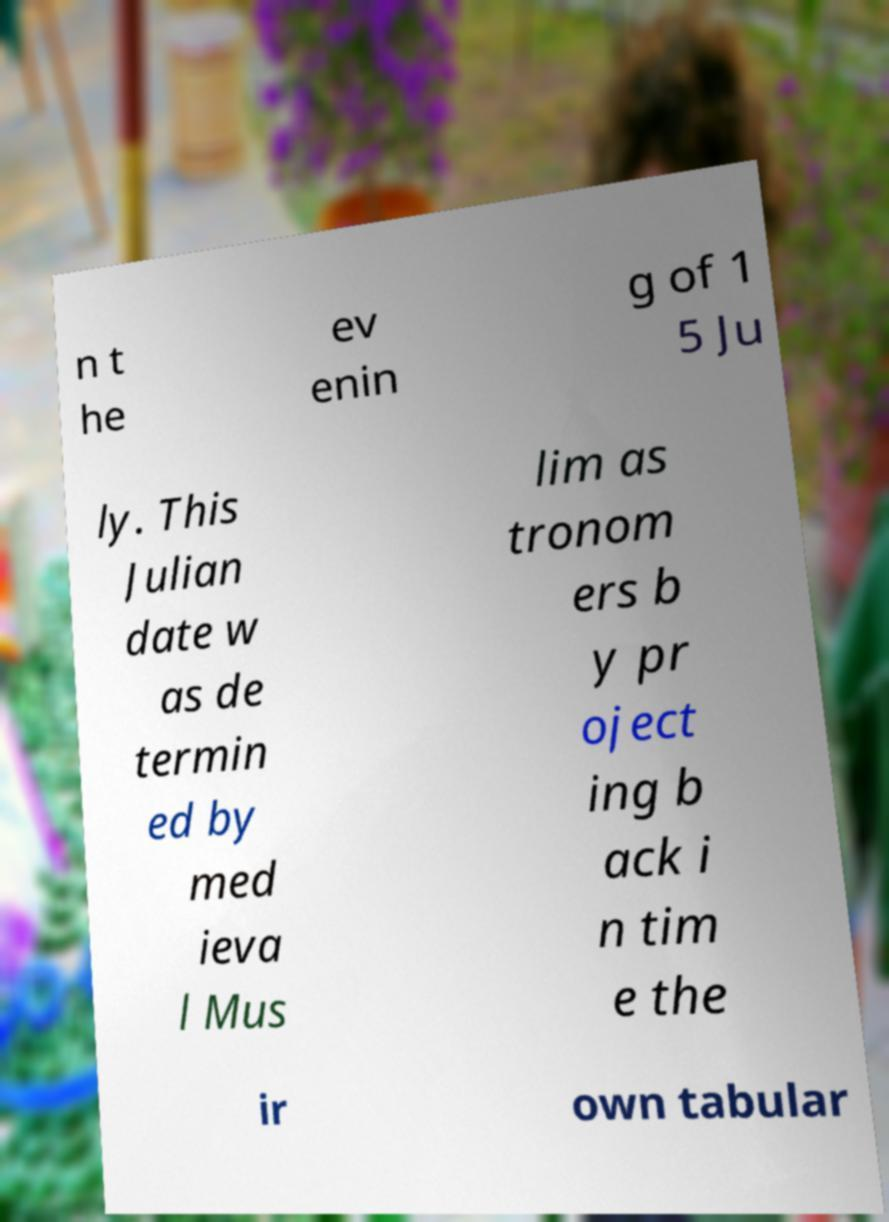Can you read and provide the text displayed in the image?This photo seems to have some interesting text. Can you extract and type it out for me? n t he ev enin g of 1 5 Ju ly. This Julian date w as de termin ed by med ieva l Mus lim as tronom ers b y pr oject ing b ack i n tim e the ir own tabular 